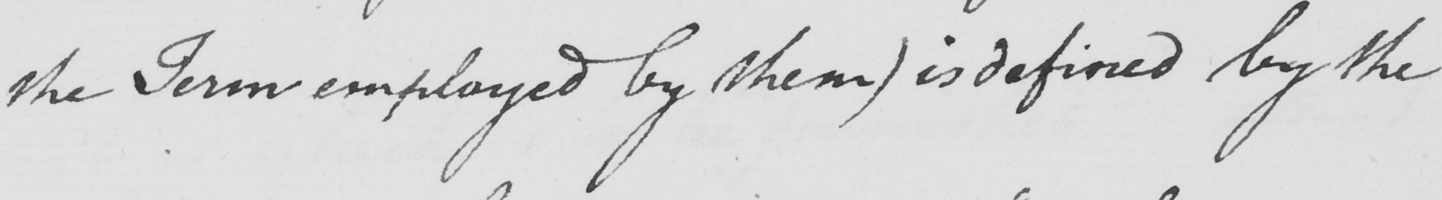Please transcribe the handwritten text in this image. the Term employed by them )  is defined by the 